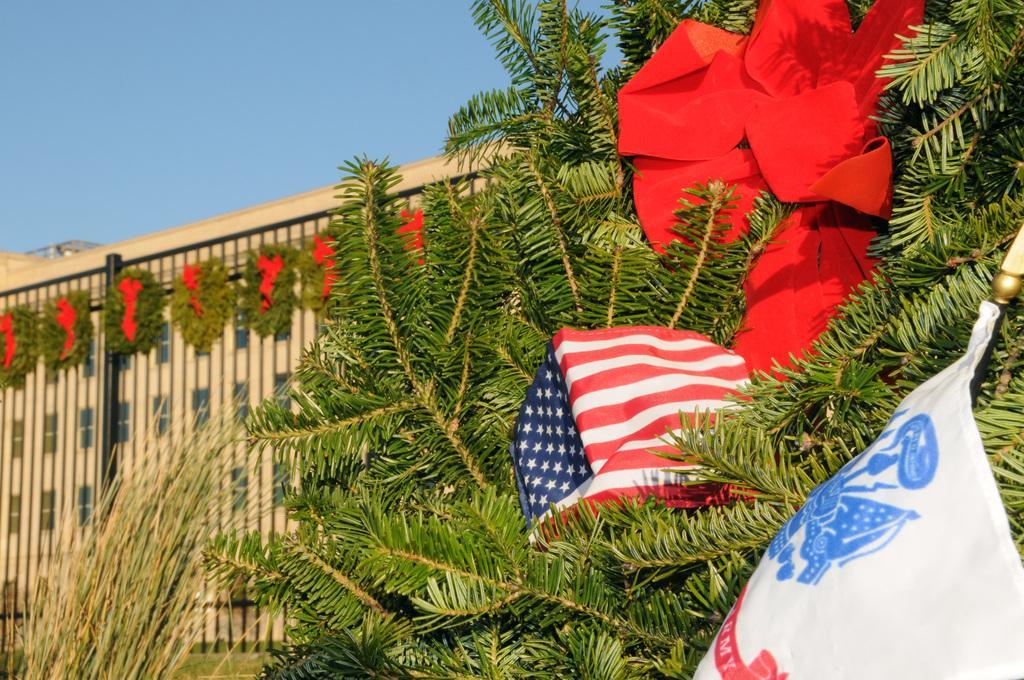Please provide a concise description of this image. In the picture we can see a plant to it, we can see a flag cloth and a ribbon and we can also see a building decorated with a ribbon and we can also see a part of the sky. 